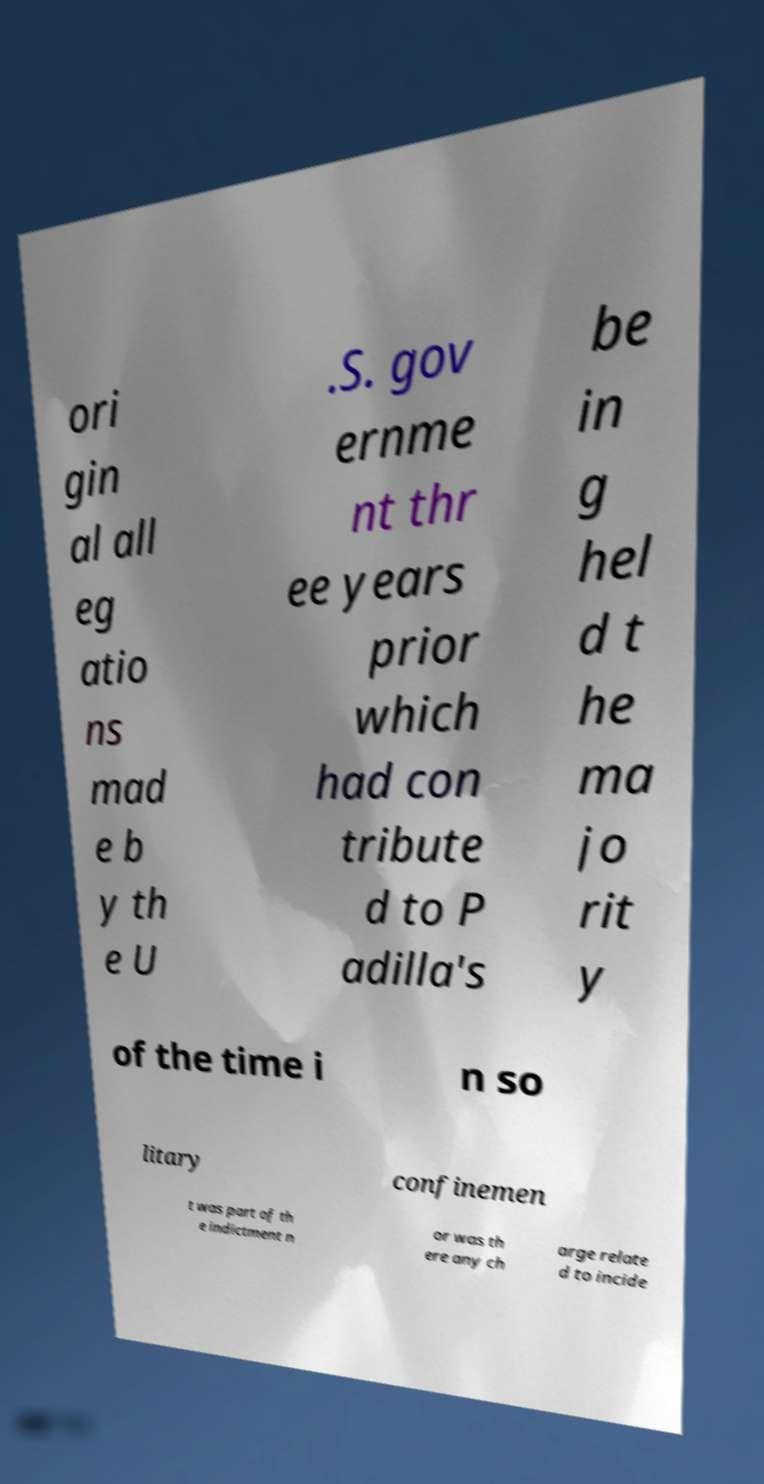There's text embedded in this image that I need extracted. Can you transcribe it verbatim? ori gin al all eg atio ns mad e b y th e U .S. gov ernme nt thr ee years prior which had con tribute d to P adilla's be in g hel d t he ma jo rit y of the time i n so litary confinemen t was part of th e indictment n or was th ere any ch arge relate d to incide 